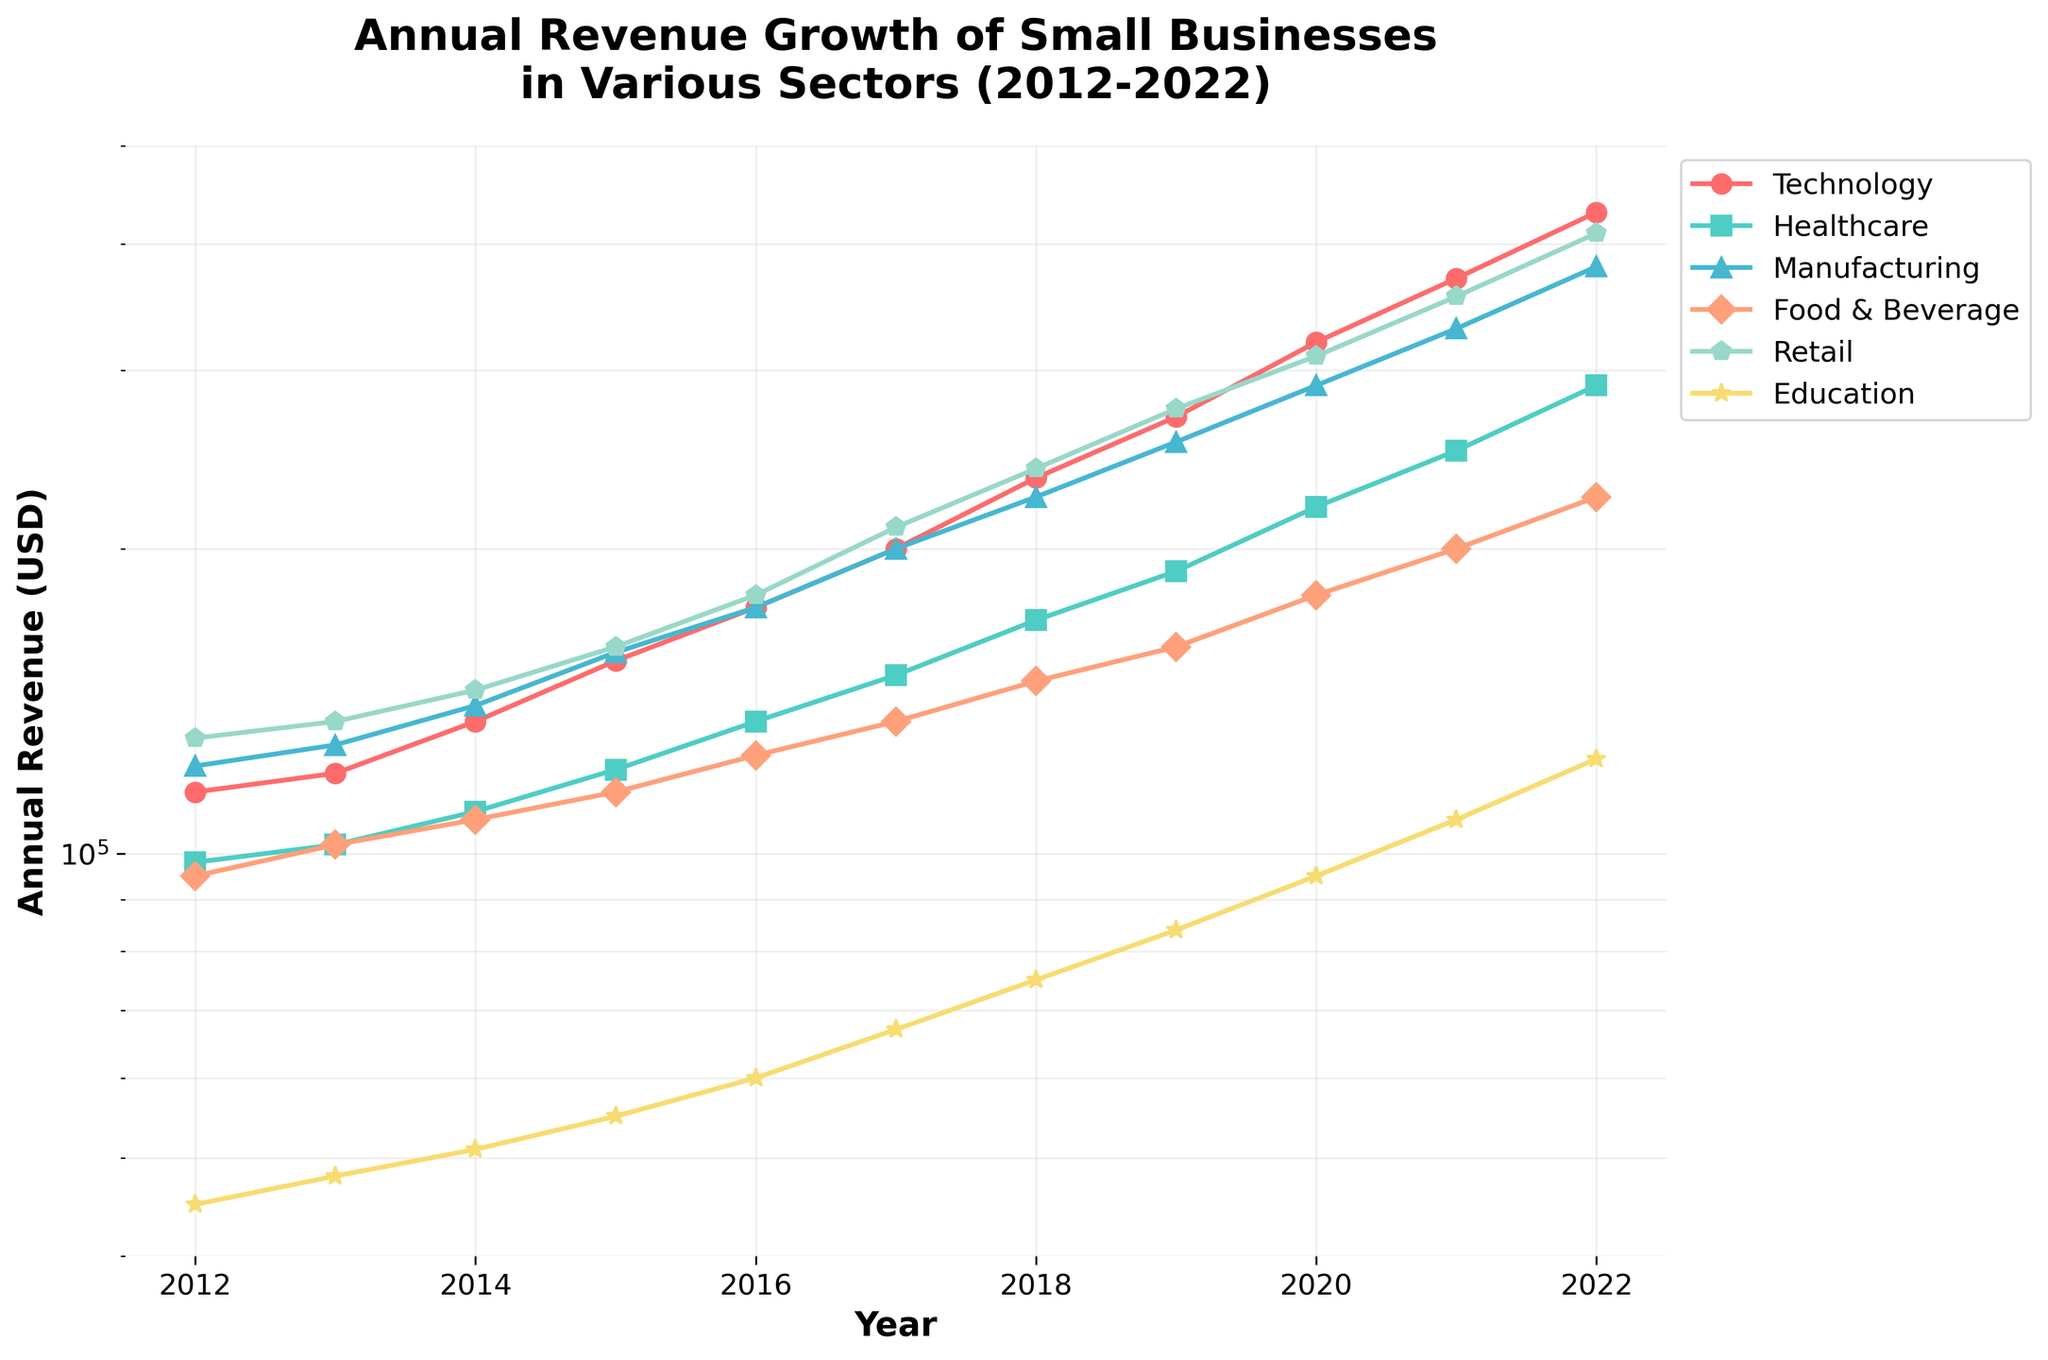What is the title of the plot? The title is typically displayed prominently at the top of the plot. For this plot, it is "Annual Revenue Growth of Small Businesses in Various Sectors (2012-2022)".
Answer: Annual Revenue Growth of Small Businesses in Various Sectors (2012-2022) How many sectors are represented in the plot? By looking at the legend, we can count the number of distinct sector names listed. The sectors presented are Technology, Healthcare, Manufacturing, Food & Beverage, Retail, and Education, making a total of six sectors.
Answer: 6 Which sector had the highest annual revenue in 2022? Referring to the end of the lines on the plot for 2022, we identify that the Retail sector had the highest revenue, positioned at the topmost point in that year.
Answer: Retail What was the annual revenue for the Technology sector in 2015? Following the line designated for the Technology sector and extracting the value from 2015, we find that it was $155,000.
Answer: $155,000 Which sector experienced the least growth between 2012 and 2022? To determine this, we look at the difference between 2022 and 2012 values for each sector. The sector with the smallest difference is Education, growing from $45,000 to $124,000.
Answer: Education For which sectors was the annual revenue higher than $200,000 in 2019? We look at the year 2019 and observe the lines above the $200,000 mark. The sectors that meet this criterion are Technology, Healthcare, Manufacturing, and Retail.
Answer: Technology, Healthcare, Manufacturing, Retail What is the difference in annual revenue between Manufacturing and Food & Beverage in 2020? In 2020, Manufacturing had $290,000 and Food & Beverage had $180,000. Subtracting these values gives a difference of $110,000.
Answer: $110,000 Which sector shows the steepest growth trend over the decade? Observing the slopes of the plotted lines on a log scale, the steepest trend implies the greatest rate of exponential growth. The Technology sector shows the steepest incline.
Answer: Technology How much did annual revenue grow for the Healthcare sector from 2012 to 2022? From the graph, Healthcare's revenue grew from $98,000 in 2012 to $290,000 in 2022. The difference is $290,000 - $98,000, which is $192,000.
Answer: $192,000 In which year did Retail surpass an annual revenue of $300,000? Tracking the Retail line, it crosses the $300,000 mark around 2020.
Answer: 2020 